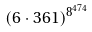<formula> <loc_0><loc_0><loc_500><loc_500>( 6 \cdot 3 6 1 ) ^ { 8 ^ { 4 7 4 } }</formula> 